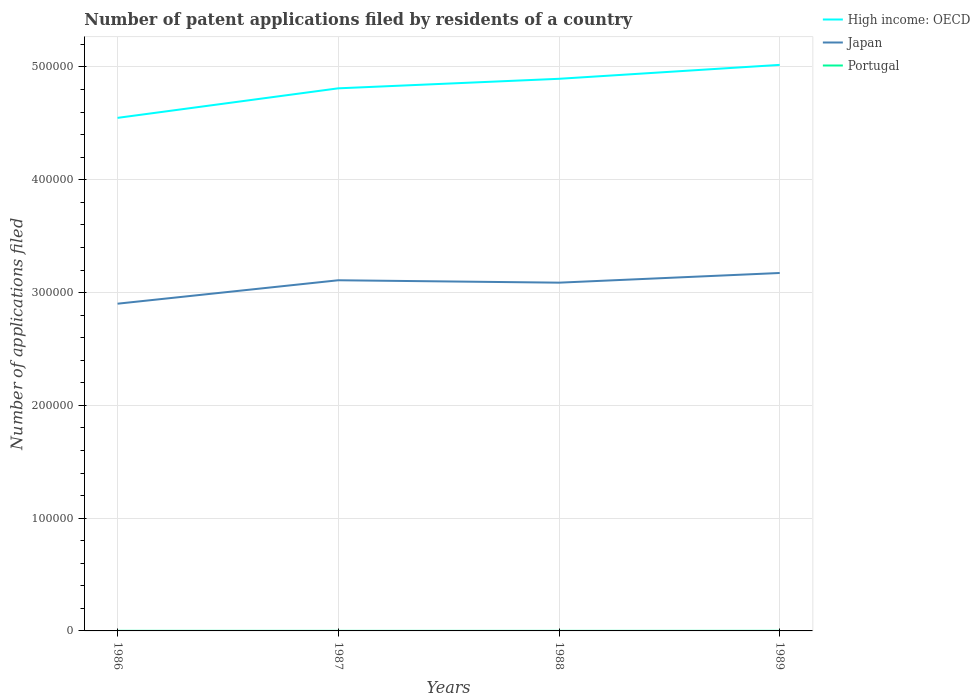Does the line corresponding to Japan intersect with the line corresponding to High income: OECD?
Provide a short and direct response. No. Is the number of lines equal to the number of legend labels?
Provide a short and direct response. Yes. Across all years, what is the maximum number of applications filed in High income: OECD?
Your answer should be very brief. 4.55e+05. What is the total number of applications filed in High income: OECD in the graph?
Your answer should be compact. -3.46e+04. What is the difference between the highest and the second highest number of applications filed in High income: OECD?
Your answer should be compact. 4.70e+04. What is the difference between the highest and the lowest number of applications filed in High income: OECD?
Offer a very short reply. 2. How many years are there in the graph?
Make the answer very short. 4. What is the difference between two consecutive major ticks on the Y-axis?
Your answer should be very brief. 1.00e+05. Are the values on the major ticks of Y-axis written in scientific E-notation?
Your response must be concise. No. Does the graph contain any zero values?
Make the answer very short. No. Does the graph contain grids?
Keep it short and to the point. Yes. Where does the legend appear in the graph?
Provide a succinct answer. Top right. What is the title of the graph?
Keep it short and to the point. Number of patent applications filed by residents of a country. What is the label or title of the Y-axis?
Make the answer very short. Number of applications filed. What is the Number of applications filed of High income: OECD in 1986?
Your answer should be compact. 4.55e+05. What is the Number of applications filed in Japan in 1986?
Keep it short and to the point. 2.90e+05. What is the Number of applications filed of High income: OECD in 1987?
Make the answer very short. 4.81e+05. What is the Number of applications filed of Japan in 1987?
Your response must be concise. 3.11e+05. What is the Number of applications filed in High income: OECD in 1988?
Ensure brevity in your answer.  4.90e+05. What is the Number of applications filed in Japan in 1988?
Offer a very short reply. 3.09e+05. What is the Number of applications filed of High income: OECD in 1989?
Your answer should be compact. 5.02e+05. What is the Number of applications filed of Japan in 1989?
Your answer should be very brief. 3.17e+05. Across all years, what is the maximum Number of applications filed of High income: OECD?
Make the answer very short. 5.02e+05. Across all years, what is the maximum Number of applications filed of Japan?
Provide a succinct answer. 3.17e+05. Across all years, what is the maximum Number of applications filed in Portugal?
Provide a short and direct response. 86. Across all years, what is the minimum Number of applications filed in High income: OECD?
Your response must be concise. 4.55e+05. Across all years, what is the minimum Number of applications filed of Japan?
Give a very brief answer. 2.90e+05. What is the total Number of applications filed of High income: OECD in the graph?
Provide a short and direct response. 1.93e+06. What is the total Number of applications filed of Japan in the graph?
Provide a succinct answer. 1.23e+06. What is the total Number of applications filed of Portugal in the graph?
Your response must be concise. 278. What is the difference between the Number of applications filed of High income: OECD in 1986 and that in 1987?
Your response must be concise. -2.62e+04. What is the difference between the Number of applications filed of Japan in 1986 and that in 1987?
Provide a short and direct response. -2.08e+04. What is the difference between the Number of applications filed in Portugal in 1986 and that in 1987?
Provide a succinct answer. 16. What is the difference between the Number of applications filed in High income: OECD in 1986 and that in 1988?
Offer a terse response. -3.46e+04. What is the difference between the Number of applications filed of Japan in 1986 and that in 1988?
Your response must be concise. -1.86e+04. What is the difference between the Number of applications filed of Portugal in 1986 and that in 1988?
Make the answer very short. 23. What is the difference between the Number of applications filed in High income: OECD in 1986 and that in 1989?
Provide a short and direct response. -4.70e+04. What is the difference between the Number of applications filed in Japan in 1986 and that in 1989?
Make the answer very short. -2.72e+04. What is the difference between the Number of applications filed of Portugal in 1986 and that in 1989?
Offer a very short reply. -9. What is the difference between the Number of applications filed in High income: OECD in 1987 and that in 1988?
Provide a succinct answer. -8446. What is the difference between the Number of applications filed of Japan in 1987 and that in 1988?
Keep it short and to the point. 2133. What is the difference between the Number of applications filed in Portugal in 1987 and that in 1988?
Your answer should be compact. 7. What is the difference between the Number of applications filed in High income: OECD in 1987 and that in 1989?
Keep it short and to the point. -2.08e+04. What is the difference between the Number of applications filed in Japan in 1987 and that in 1989?
Provide a short and direct response. -6445. What is the difference between the Number of applications filed in High income: OECD in 1988 and that in 1989?
Your response must be concise. -1.23e+04. What is the difference between the Number of applications filed of Japan in 1988 and that in 1989?
Provide a succinct answer. -8578. What is the difference between the Number of applications filed in Portugal in 1988 and that in 1989?
Give a very brief answer. -32. What is the difference between the Number of applications filed in High income: OECD in 1986 and the Number of applications filed in Japan in 1987?
Ensure brevity in your answer.  1.44e+05. What is the difference between the Number of applications filed in High income: OECD in 1986 and the Number of applications filed in Portugal in 1987?
Provide a short and direct response. 4.55e+05. What is the difference between the Number of applications filed of Japan in 1986 and the Number of applications filed of Portugal in 1987?
Your answer should be compact. 2.90e+05. What is the difference between the Number of applications filed in High income: OECD in 1986 and the Number of applications filed in Japan in 1988?
Keep it short and to the point. 1.46e+05. What is the difference between the Number of applications filed of High income: OECD in 1986 and the Number of applications filed of Portugal in 1988?
Provide a short and direct response. 4.55e+05. What is the difference between the Number of applications filed in Japan in 1986 and the Number of applications filed in Portugal in 1988?
Keep it short and to the point. 2.90e+05. What is the difference between the Number of applications filed in High income: OECD in 1986 and the Number of applications filed in Japan in 1989?
Give a very brief answer. 1.38e+05. What is the difference between the Number of applications filed in High income: OECD in 1986 and the Number of applications filed in Portugal in 1989?
Your response must be concise. 4.55e+05. What is the difference between the Number of applications filed of Japan in 1986 and the Number of applications filed of Portugal in 1989?
Offer a terse response. 2.90e+05. What is the difference between the Number of applications filed in High income: OECD in 1987 and the Number of applications filed in Japan in 1988?
Offer a very short reply. 1.72e+05. What is the difference between the Number of applications filed of High income: OECD in 1987 and the Number of applications filed of Portugal in 1988?
Keep it short and to the point. 4.81e+05. What is the difference between the Number of applications filed in Japan in 1987 and the Number of applications filed in Portugal in 1988?
Ensure brevity in your answer.  3.11e+05. What is the difference between the Number of applications filed of High income: OECD in 1987 and the Number of applications filed of Japan in 1989?
Make the answer very short. 1.64e+05. What is the difference between the Number of applications filed in High income: OECD in 1987 and the Number of applications filed in Portugal in 1989?
Your answer should be compact. 4.81e+05. What is the difference between the Number of applications filed in Japan in 1987 and the Number of applications filed in Portugal in 1989?
Make the answer very short. 3.11e+05. What is the difference between the Number of applications filed of High income: OECD in 1988 and the Number of applications filed of Japan in 1989?
Make the answer very short. 1.72e+05. What is the difference between the Number of applications filed in High income: OECD in 1988 and the Number of applications filed in Portugal in 1989?
Offer a terse response. 4.89e+05. What is the difference between the Number of applications filed in Japan in 1988 and the Number of applications filed in Portugal in 1989?
Give a very brief answer. 3.09e+05. What is the average Number of applications filed in High income: OECD per year?
Give a very brief answer. 4.82e+05. What is the average Number of applications filed in Japan per year?
Your answer should be compact. 3.07e+05. What is the average Number of applications filed in Portugal per year?
Your answer should be compact. 69.5. In the year 1986, what is the difference between the Number of applications filed of High income: OECD and Number of applications filed of Japan?
Provide a short and direct response. 1.65e+05. In the year 1986, what is the difference between the Number of applications filed in High income: OECD and Number of applications filed in Portugal?
Your response must be concise. 4.55e+05. In the year 1986, what is the difference between the Number of applications filed of Japan and Number of applications filed of Portugal?
Your response must be concise. 2.90e+05. In the year 1987, what is the difference between the Number of applications filed of High income: OECD and Number of applications filed of Japan?
Your answer should be very brief. 1.70e+05. In the year 1987, what is the difference between the Number of applications filed in High income: OECD and Number of applications filed in Portugal?
Give a very brief answer. 4.81e+05. In the year 1987, what is the difference between the Number of applications filed in Japan and Number of applications filed in Portugal?
Your answer should be very brief. 3.11e+05. In the year 1988, what is the difference between the Number of applications filed of High income: OECD and Number of applications filed of Japan?
Keep it short and to the point. 1.81e+05. In the year 1988, what is the difference between the Number of applications filed in High income: OECD and Number of applications filed in Portugal?
Make the answer very short. 4.89e+05. In the year 1988, what is the difference between the Number of applications filed in Japan and Number of applications filed in Portugal?
Provide a short and direct response. 3.09e+05. In the year 1989, what is the difference between the Number of applications filed of High income: OECD and Number of applications filed of Japan?
Ensure brevity in your answer.  1.85e+05. In the year 1989, what is the difference between the Number of applications filed in High income: OECD and Number of applications filed in Portugal?
Your answer should be compact. 5.02e+05. In the year 1989, what is the difference between the Number of applications filed in Japan and Number of applications filed in Portugal?
Offer a terse response. 3.17e+05. What is the ratio of the Number of applications filed in High income: OECD in 1986 to that in 1987?
Ensure brevity in your answer.  0.95. What is the ratio of the Number of applications filed in Japan in 1986 to that in 1987?
Offer a terse response. 0.93. What is the ratio of the Number of applications filed of Portugal in 1986 to that in 1987?
Make the answer very short. 1.26. What is the ratio of the Number of applications filed of High income: OECD in 1986 to that in 1988?
Ensure brevity in your answer.  0.93. What is the ratio of the Number of applications filed of Japan in 1986 to that in 1988?
Your answer should be very brief. 0.94. What is the ratio of the Number of applications filed in Portugal in 1986 to that in 1988?
Your answer should be compact. 1.43. What is the ratio of the Number of applications filed of High income: OECD in 1986 to that in 1989?
Your answer should be compact. 0.91. What is the ratio of the Number of applications filed in Japan in 1986 to that in 1989?
Provide a short and direct response. 0.91. What is the ratio of the Number of applications filed in Portugal in 1986 to that in 1989?
Offer a terse response. 0.9. What is the ratio of the Number of applications filed in High income: OECD in 1987 to that in 1988?
Ensure brevity in your answer.  0.98. What is the ratio of the Number of applications filed of Japan in 1987 to that in 1988?
Offer a very short reply. 1.01. What is the ratio of the Number of applications filed of Portugal in 1987 to that in 1988?
Offer a very short reply. 1.13. What is the ratio of the Number of applications filed in High income: OECD in 1987 to that in 1989?
Offer a terse response. 0.96. What is the ratio of the Number of applications filed in Japan in 1987 to that in 1989?
Make the answer very short. 0.98. What is the ratio of the Number of applications filed of Portugal in 1987 to that in 1989?
Provide a succinct answer. 0.71. What is the ratio of the Number of applications filed of High income: OECD in 1988 to that in 1989?
Keep it short and to the point. 0.98. What is the ratio of the Number of applications filed in Portugal in 1988 to that in 1989?
Offer a very short reply. 0.63. What is the difference between the highest and the second highest Number of applications filed of High income: OECD?
Give a very brief answer. 1.23e+04. What is the difference between the highest and the second highest Number of applications filed of Japan?
Give a very brief answer. 6445. What is the difference between the highest and the second highest Number of applications filed of Portugal?
Your answer should be compact. 9. What is the difference between the highest and the lowest Number of applications filed of High income: OECD?
Ensure brevity in your answer.  4.70e+04. What is the difference between the highest and the lowest Number of applications filed in Japan?
Your answer should be very brief. 2.72e+04. 